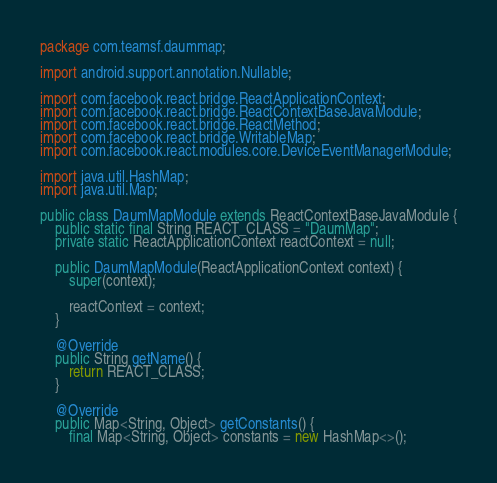Convert code to text. <code><loc_0><loc_0><loc_500><loc_500><_Java_>package com.teamsf.daummap;

import android.support.annotation.Nullable;

import com.facebook.react.bridge.ReactApplicationContext;
import com.facebook.react.bridge.ReactContextBaseJavaModule;
import com.facebook.react.bridge.ReactMethod;
import com.facebook.react.bridge.WritableMap;
import com.facebook.react.modules.core.DeviceEventManagerModule;

import java.util.HashMap;
import java.util.Map;

public class DaumMapModule extends ReactContextBaseJavaModule {
	public static final String REACT_CLASS = "DaumMap";
	private static ReactApplicationContext reactContext = null;

	public DaumMapModule(ReactApplicationContext context) {
		super(context);

		reactContext = context;
	}

	@Override
	public String getName() {
		return REACT_CLASS;
	}

	@Override
	public Map<String, Object> getConstants() {
		final Map<String, Object> constants = new HashMap<>();</code> 